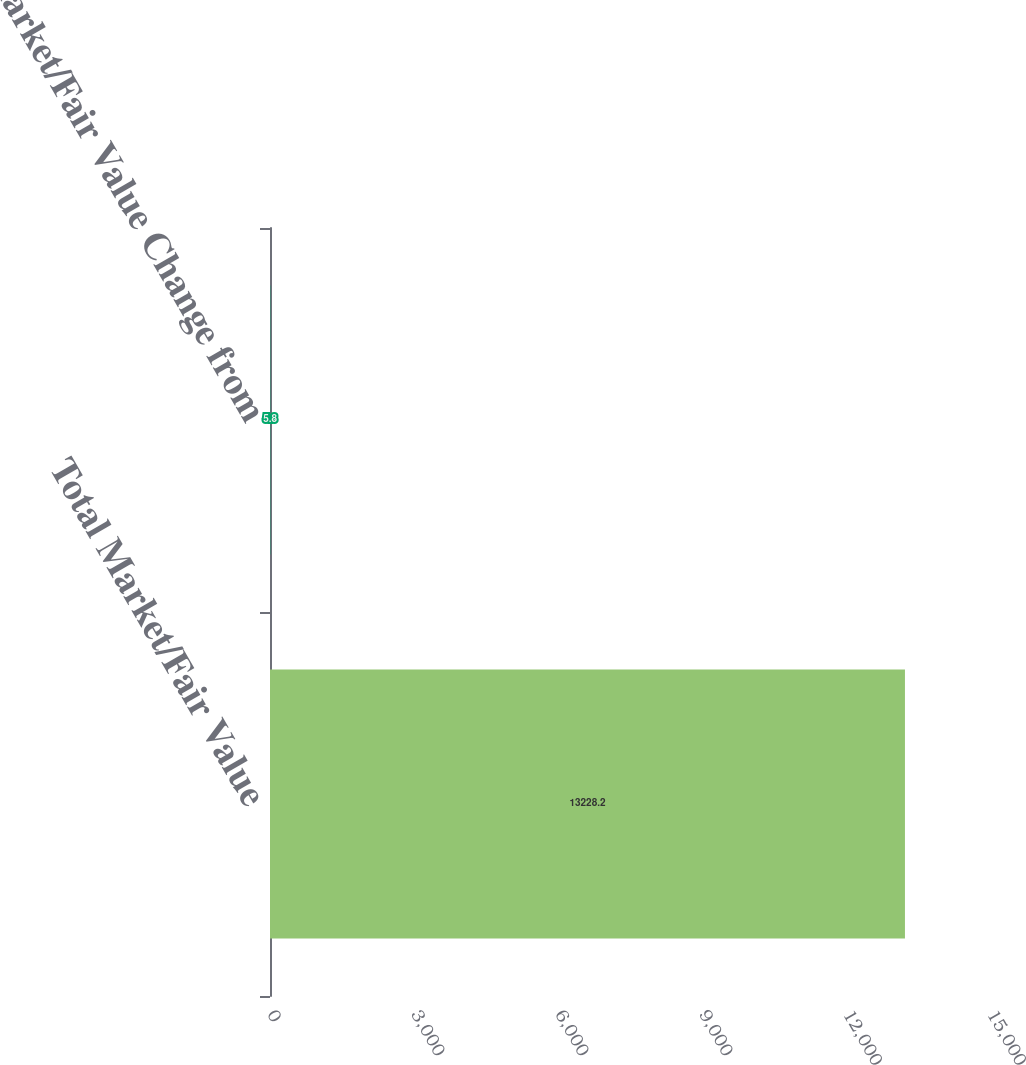Convert chart to OTSL. <chart><loc_0><loc_0><loc_500><loc_500><bar_chart><fcel>Total Market/Fair Value<fcel>Market/Fair Value Change from<nl><fcel>13228.2<fcel>5.8<nl></chart> 